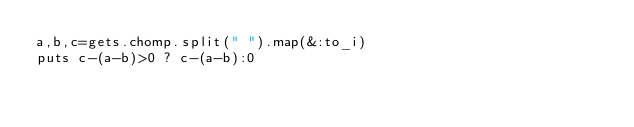Convert code to text. <code><loc_0><loc_0><loc_500><loc_500><_Ruby_>a,b,c=gets.chomp.split(" ").map(&:to_i)
puts c-(a-b)>0 ? c-(a-b):0
</code> 